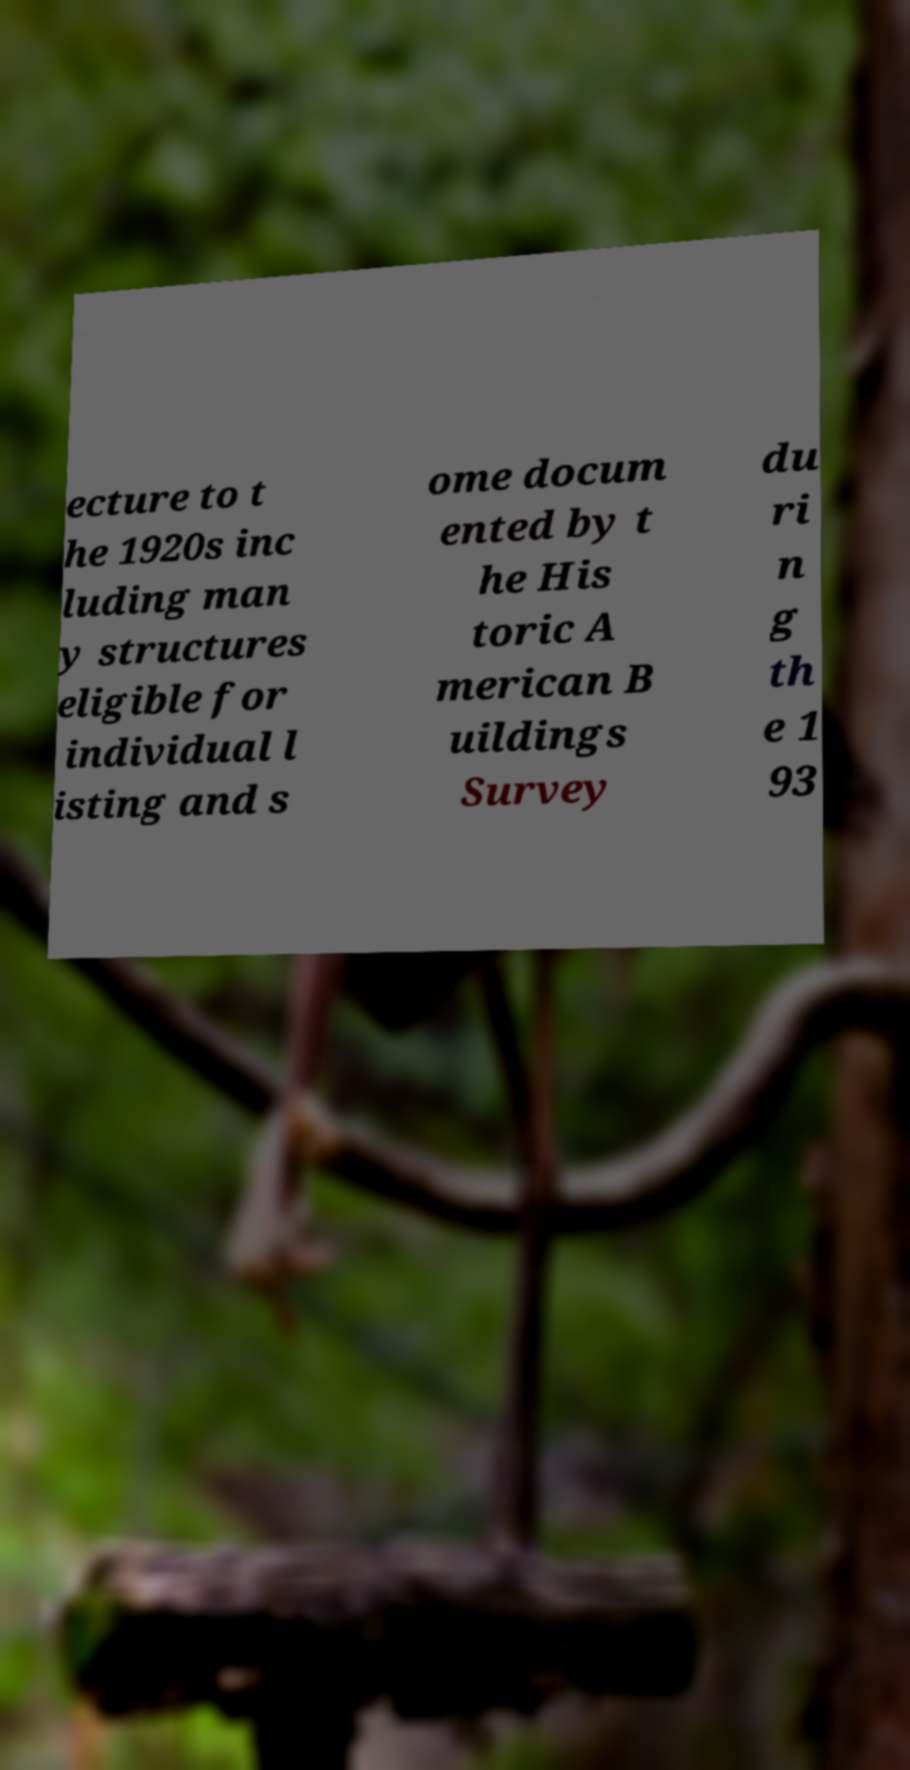For documentation purposes, I need the text within this image transcribed. Could you provide that? ecture to t he 1920s inc luding man y structures eligible for individual l isting and s ome docum ented by t he His toric A merican B uildings Survey du ri n g th e 1 93 